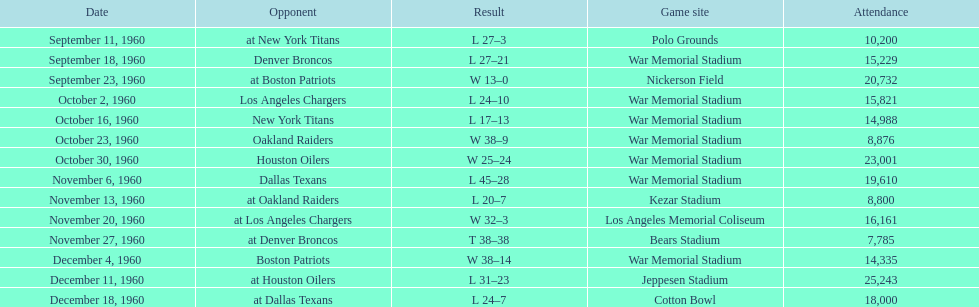How many games had an attendance of 10,000 at most? 11. 